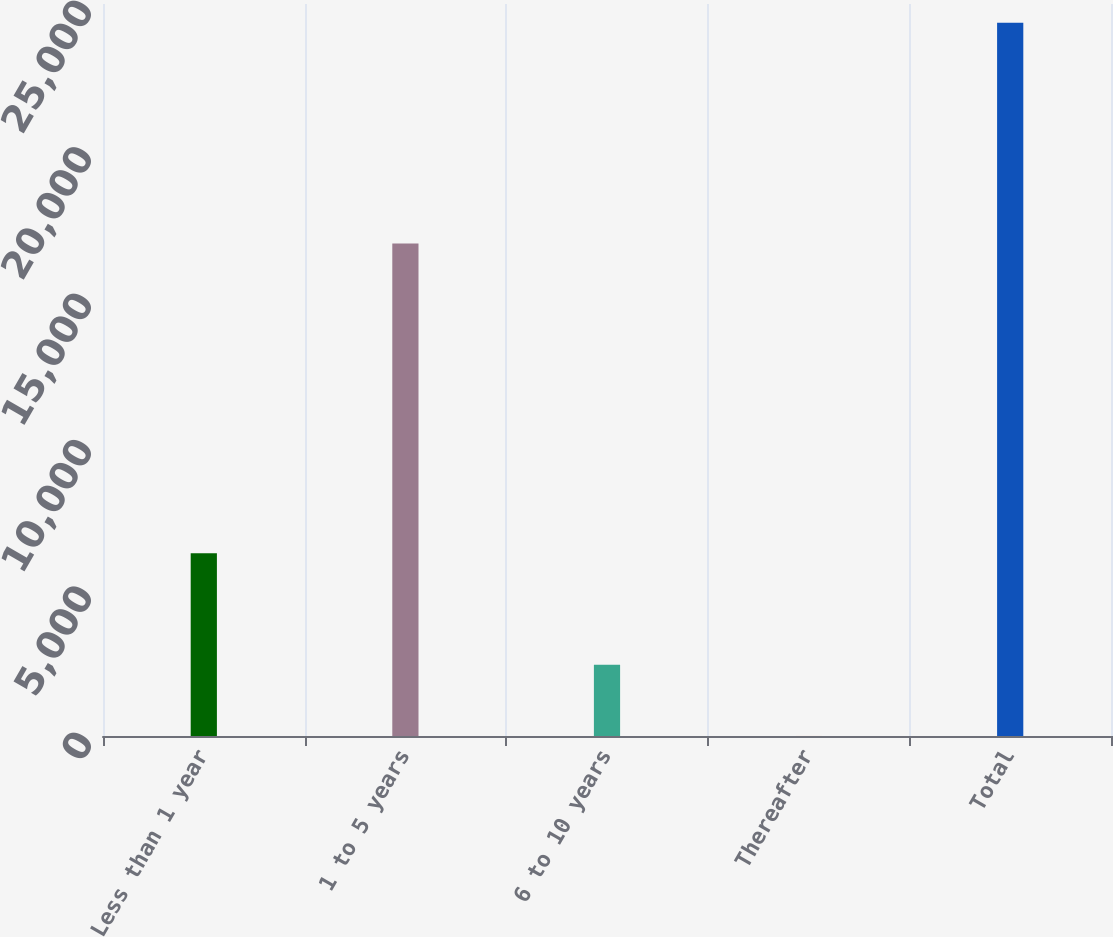<chart> <loc_0><loc_0><loc_500><loc_500><bar_chart><fcel>Less than 1 year<fcel>1 to 5 years<fcel>6 to 10 years<fcel>Thereafter<fcel>Total<nl><fcel>6241<fcel>16824<fcel>2437.45<fcel>1.61<fcel>24360<nl></chart> 